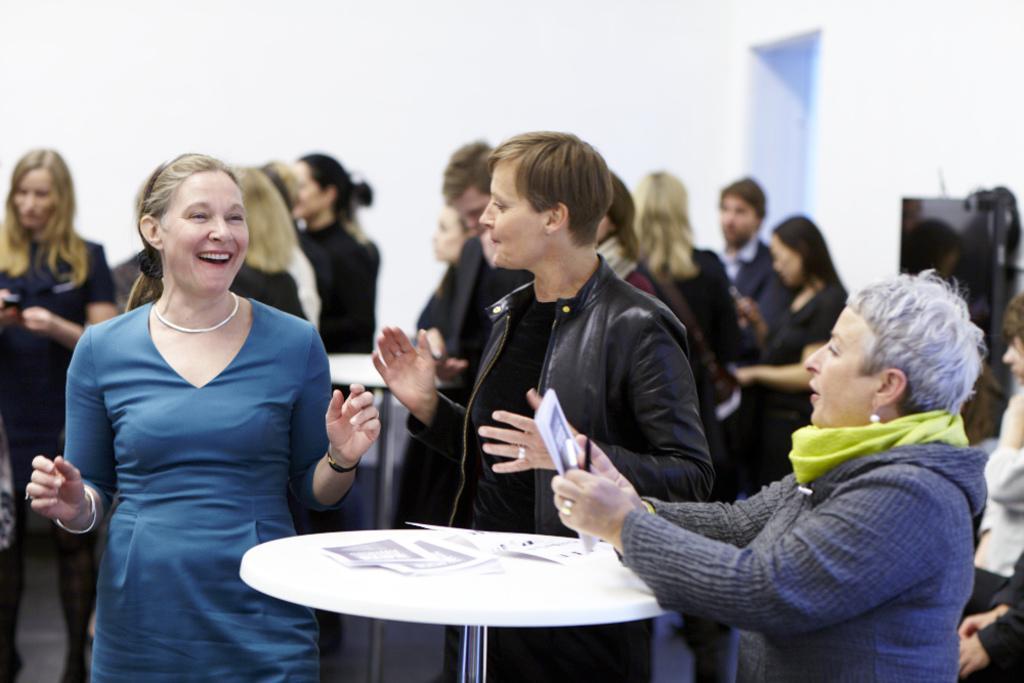How would you summarize this image in a sentence or two? Three women are standing at a table and talking. There are some papers on the table. There some other people at tables behind them. 